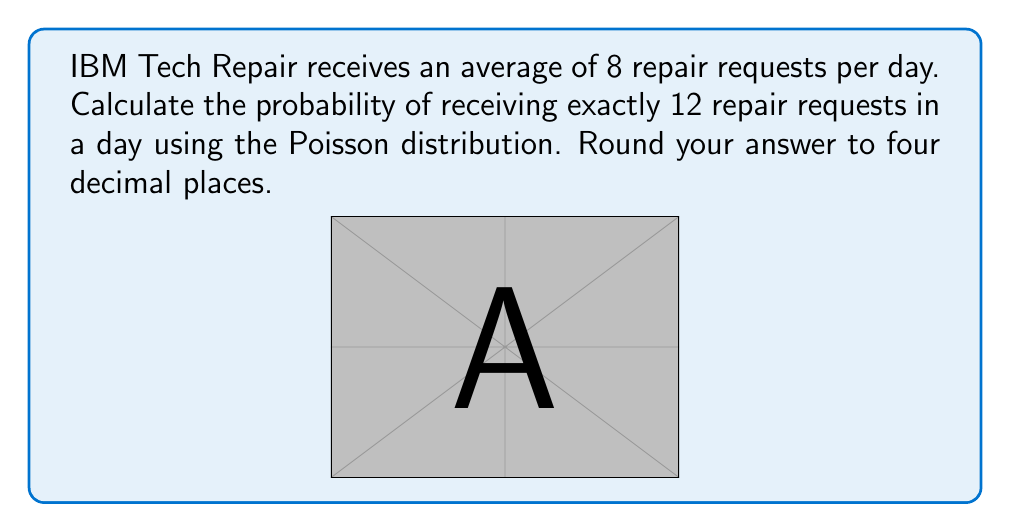Provide a solution to this math problem. To solve this problem, we'll use the Poisson distribution formula:

$$P(X = k) = \frac{e^{-\lambda} \lambda^k}{k!}$$

Where:
$\lambda$ = average number of events in the interval
$k$ = number of events we're calculating the probability for
$e$ = Euler's number (approximately 2.71828)

Given:
$\lambda = 8$ (average repair requests per day)
$k = 12$ (number of repair requests we're calculating the probability for)

Step 1: Substitute the values into the formula
$$P(X = 12) = \frac{e^{-8} 8^{12}}{12!}$$

Step 2: Calculate $e^{-8}$
$e^{-8} \approx 0.000335463$

Step 3: Calculate $8^{12}$
$8^{12} = 68,719,476,736$

Step 4: Calculate $12!$
$12! = 479,001,600$

Step 5: Put it all together
$$P(X = 12) = \frac{0.000335463 \times 68,719,476,736}{479,001,600}$$

Step 6: Perform the calculation
$P(X = 12) \approx 0.0482$

Therefore, the probability of receiving exactly 12 repair requests in a day is approximately 0.0482 or 4.82%.
Answer: 0.0482 